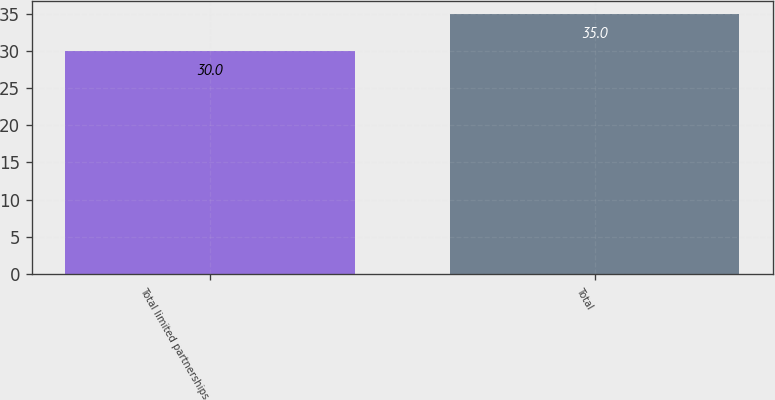<chart> <loc_0><loc_0><loc_500><loc_500><bar_chart><fcel>Total limited partnerships<fcel>Total<nl><fcel>30<fcel>35<nl></chart> 